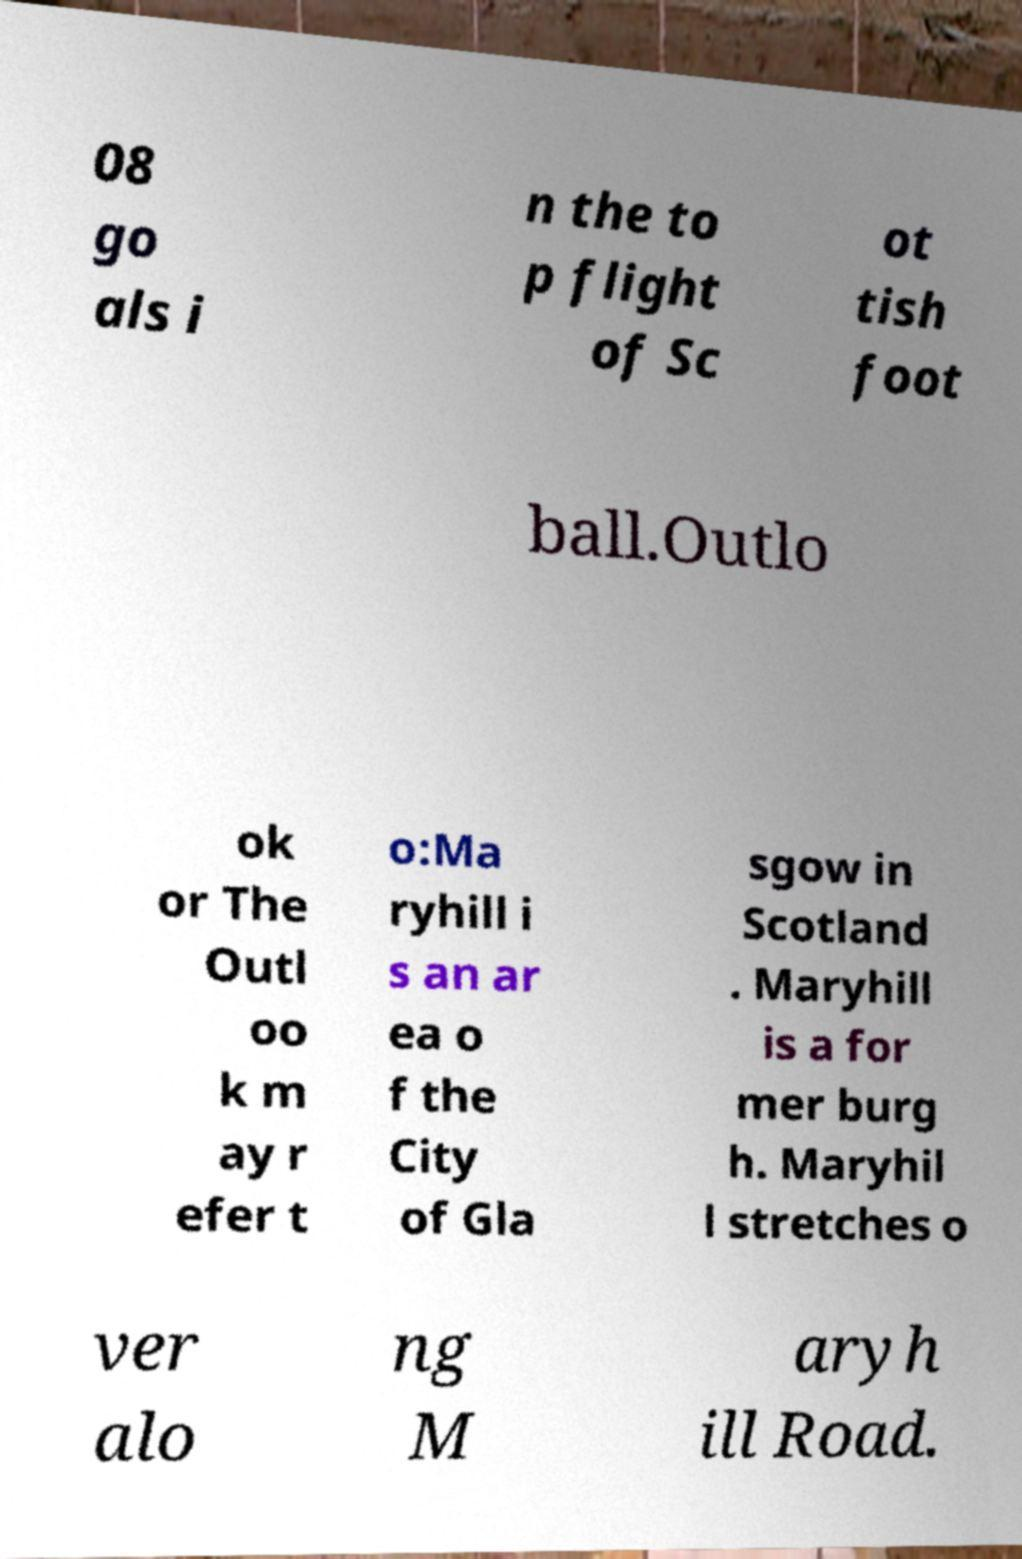Could you extract and type out the text from this image? 08 go als i n the to p flight of Sc ot tish foot ball.Outlo ok or The Outl oo k m ay r efer t o:Ma ryhill i s an ar ea o f the City of Gla sgow in Scotland . Maryhill is a for mer burg h. Maryhil l stretches o ver alo ng M aryh ill Road. 